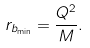<formula> <loc_0><loc_0><loc_500><loc_500>r _ { b _ { \min } } = \frac { Q ^ { 2 } } { M } .</formula> 